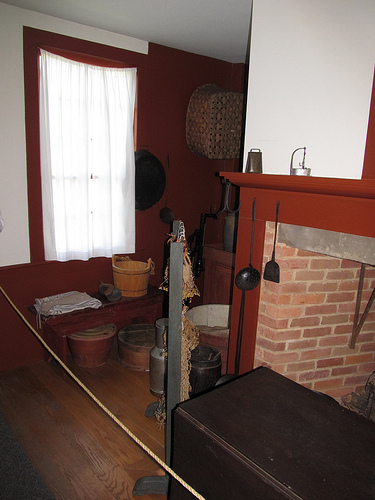What era does the interior design of this room suggest? The room's design, featuring a brick fireplace, rustic metal pots, and wooden buckets, suggests an earlier historical period, perhaps colonial American or a traditional farmhouse style. 